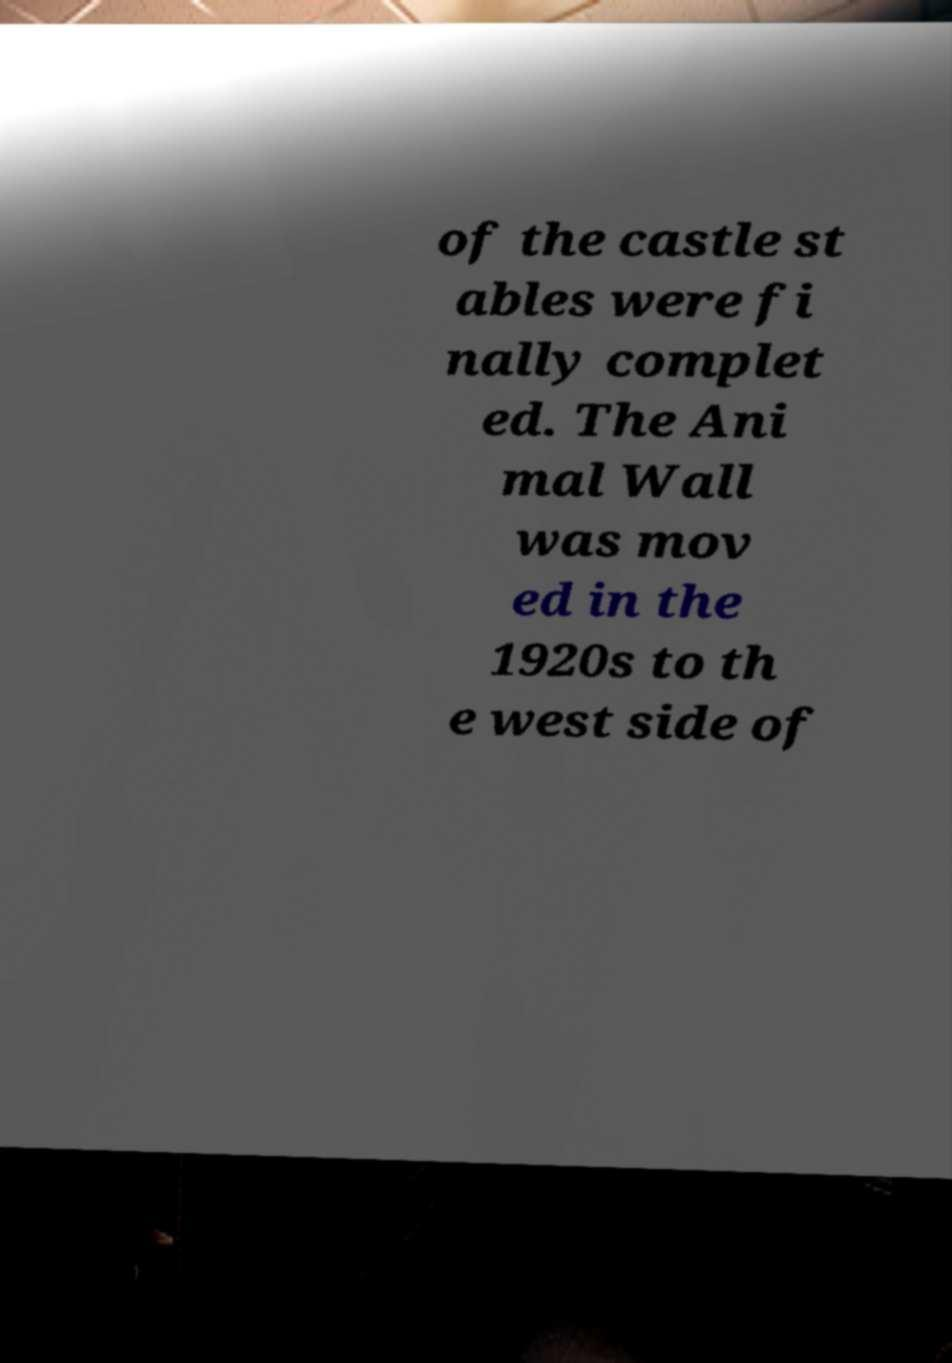For documentation purposes, I need the text within this image transcribed. Could you provide that? of the castle st ables were fi nally complet ed. The Ani mal Wall was mov ed in the 1920s to th e west side of 